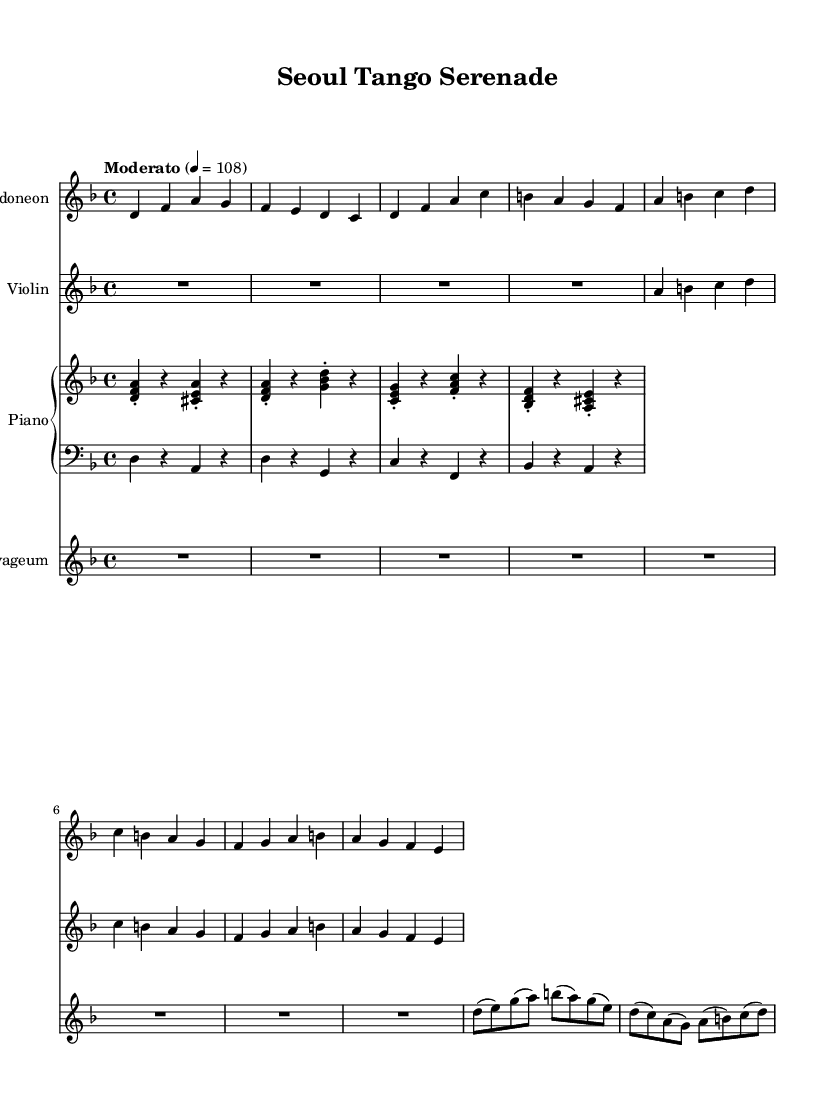What is the key signature of this music? The key signature has two flats, indicating it is in D minor. The key signature is indicated by the sharps or flats shown at the beginning of the staff.
Answer: D minor What is the time signature of this music? The time signature is shown as 4/4, meaning there are four beats in each measure and the quarter note gets one beat. This is clearly indicated at the beginning of the score.
Answer: 4/4 What is the tempo marking of this piece? The tempo marking is "Moderato," indicating a moderate speed for the piece. This is indicated at the beginning of the score where the tempo is marked.
Answer: Moderato Which instruments are featured in this piece? The instruments featured are bandoneon, violin, piano, contrabass, and gayageum. Each instrument is indicated at the start of its corresponding staff in the score.
Answer: Bandoneon, violin, piano, contrabass, gayageum How many beats are in a measure? There are four beats in each measure as indicated by the time signature of 4/4. This means each measure contains four quarter-note beats.
Answer: 4 What genre does this piece represent? This piece represents the contemporary fusion genre, specifically Argentinian tango fused with classical Korean music, as inferred from the instrumentation and cultural influence.
Answer: Argentinian tango fusion 